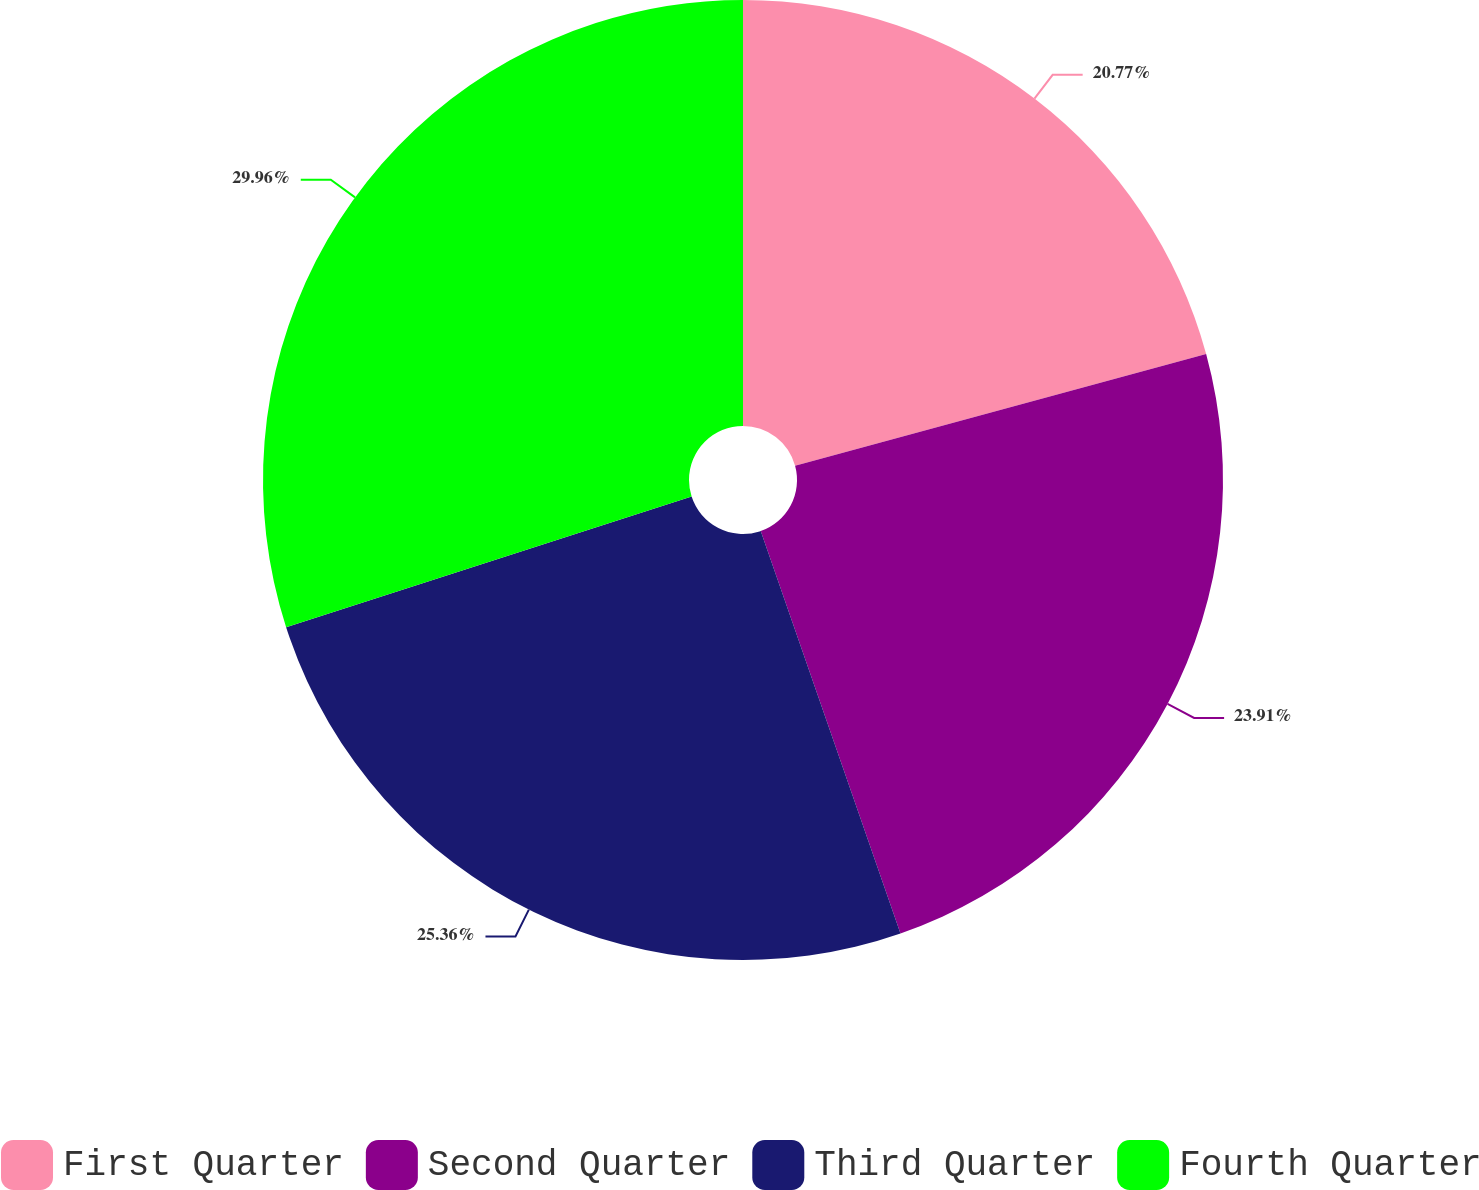<chart> <loc_0><loc_0><loc_500><loc_500><pie_chart><fcel>First Quarter<fcel>Second Quarter<fcel>Third Quarter<fcel>Fourth Quarter<nl><fcel>20.77%<fcel>23.91%<fcel>25.36%<fcel>29.96%<nl></chart> 